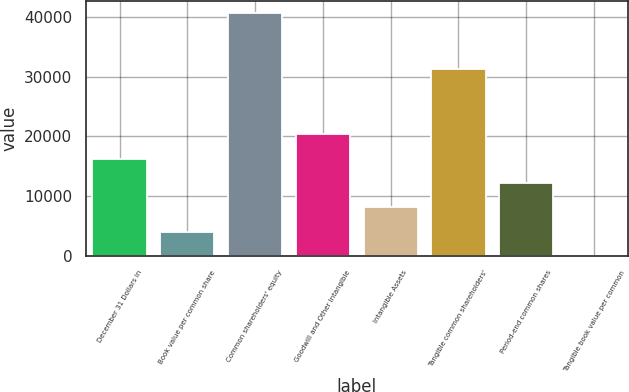Convert chart. <chart><loc_0><loc_0><loc_500><loc_500><bar_chart><fcel>December 31 Dollars in<fcel>Book value per common share<fcel>Common shareholders' equity<fcel>Goodwill and Other Intangible<fcel>Intangible Assets<fcel>Tangible common shareholders'<fcel>Period-end common shares<fcel>Tangible book value per common<nl><fcel>16277.9<fcel>4114.39<fcel>40605<fcel>20332.4<fcel>8168.9<fcel>31330<fcel>12223.4<fcel>59.88<nl></chart> 